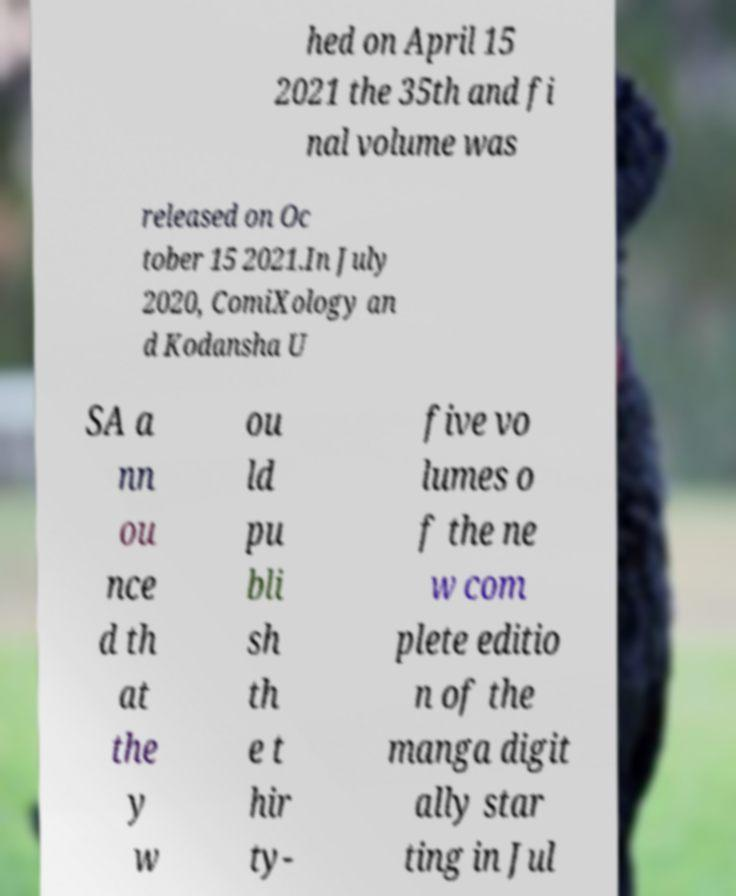Could you extract and type out the text from this image? hed on April 15 2021 the 35th and fi nal volume was released on Oc tober 15 2021.In July 2020, ComiXology an d Kodansha U SA a nn ou nce d th at the y w ou ld pu bli sh th e t hir ty- five vo lumes o f the ne w com plete editio n of the manga digit ally star ting in Jul 